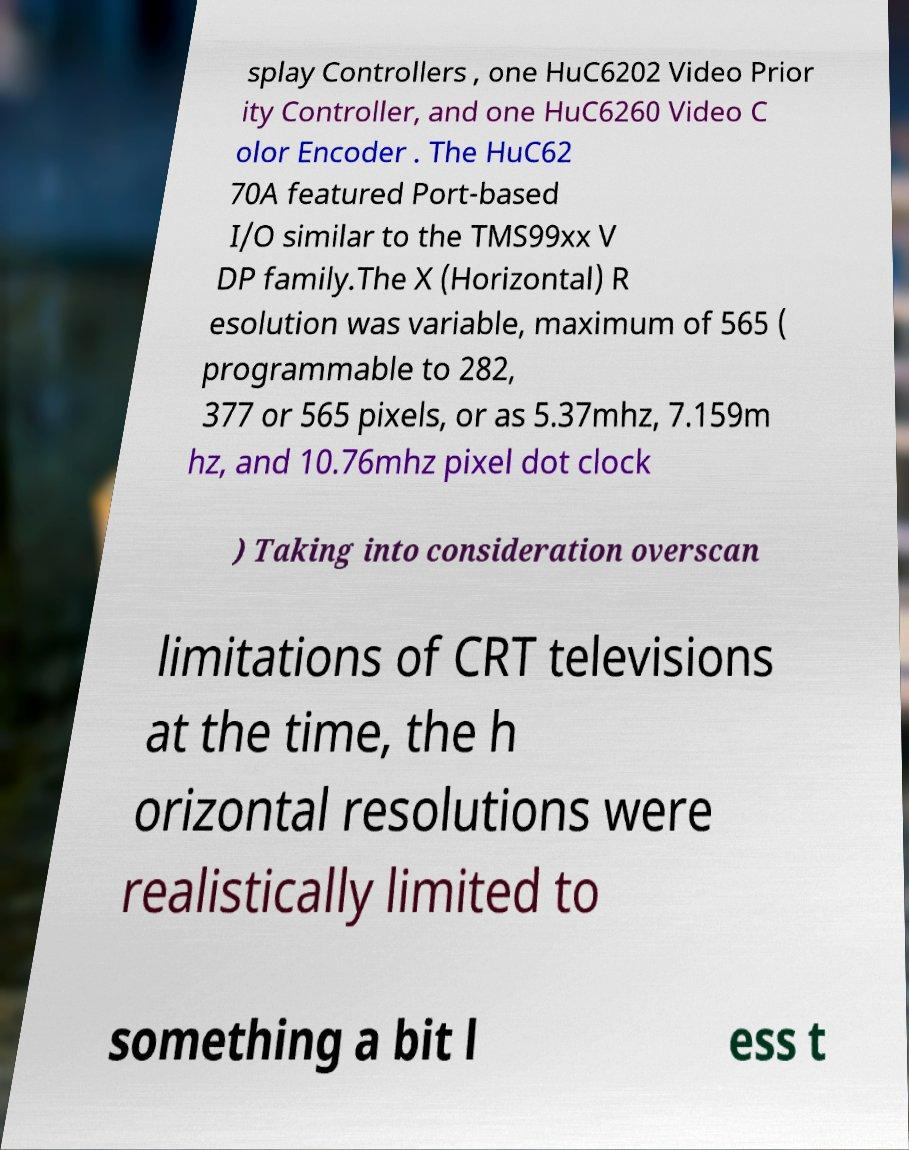Could you extract and type out the text from this image? splay Controllers , one HuC6202 Video Prior ity Controller, and one HuC6260 Video C olor Encoder . The HuC62 70A featured Port-based I/O similar to the TMS99xx V DP family.The X (Horizontal) R esolution was variable, maximum of 565 ( programmable to 282, 377 or 565 pixels, or as 5.37mhz, 7.159m hz, and 10.76mhz pixel dot clock ) Taking into consideration overscan limitations of CRT televisions at the time, the h orizontal resolutions were realistically limited to something a bit l ess t 